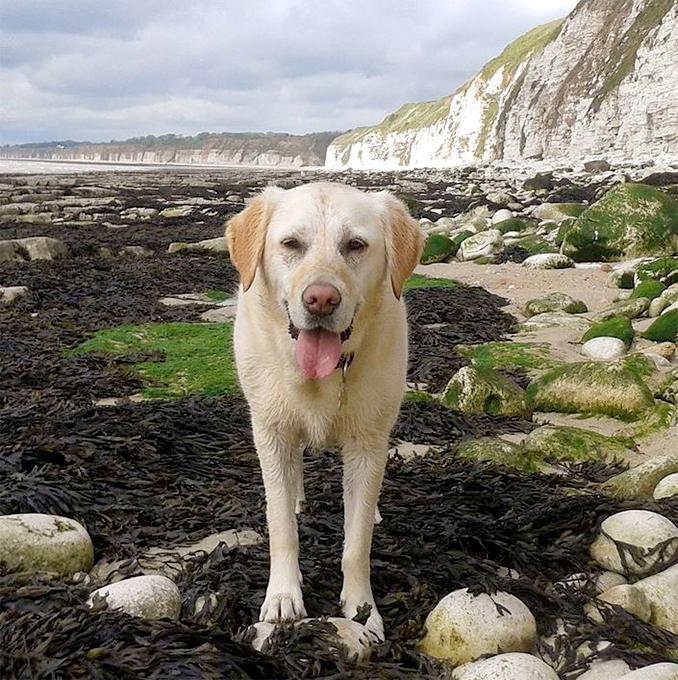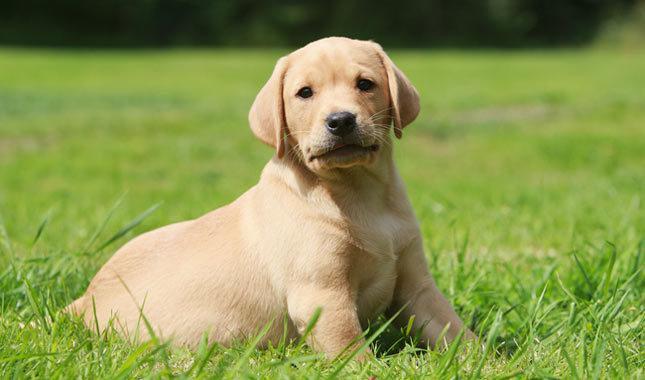The first image is the image on the left, the second image is the image on the right. For the images displayed, is the sentence "Only one of the dogs is black." factually correct? Answer yes or no. No. 